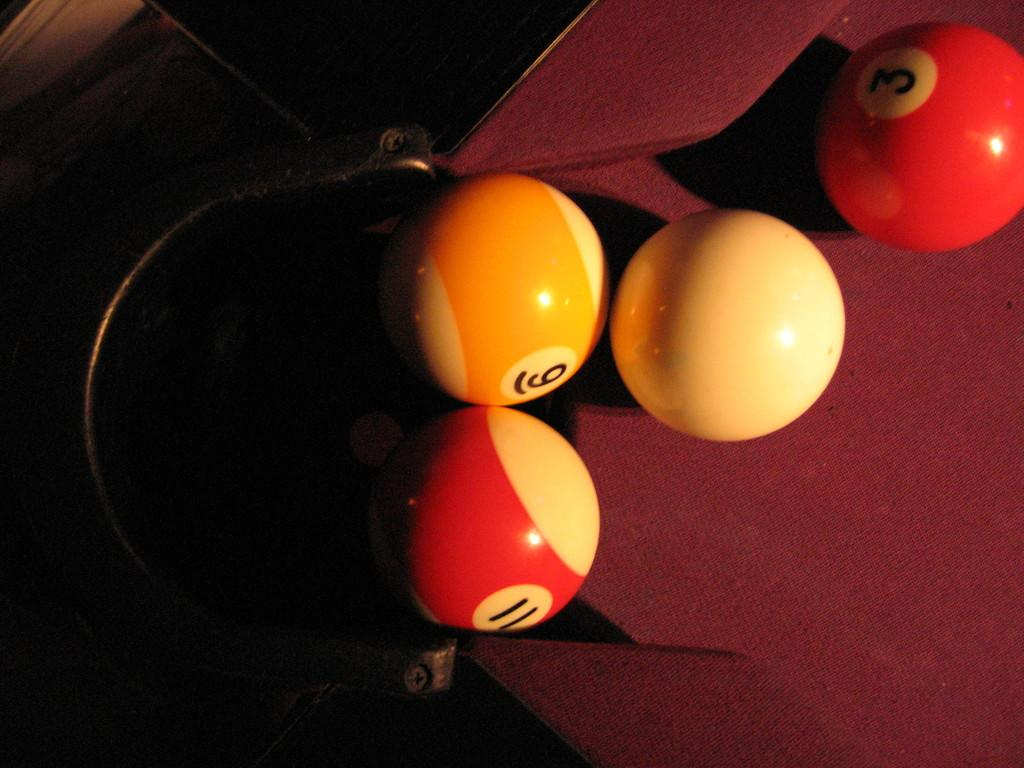<image>
Share a concise interpretation of the image provided. A pool table with the number eleven, six and three written on them and the white ball. 